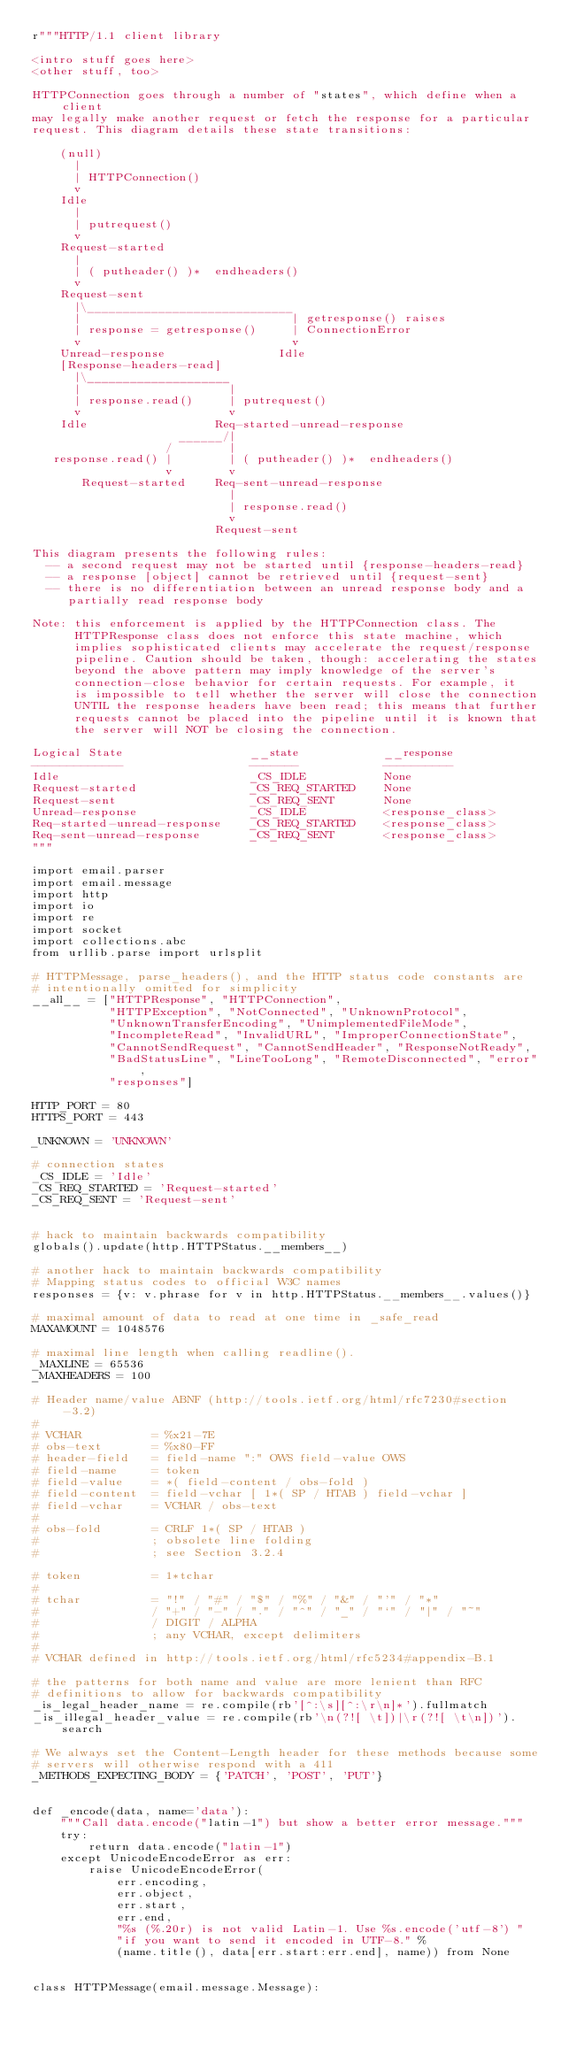Convert code to text. <code><loc_0><loc_0><loc_500><loc_500><_Python_>r"""HTTP/1.1 client library

<intro stuff goes here>
<other stuff, too>

HTTPConnection goes through a number of "states", which define when a client
may legally make another request or fetch the response for a particular
request. This diagram details these state transitions:

    (null)
      |
      | HTTPConnection()
      v
    Idle
      |
      | putrequest()
      v
    Request-started
      |
      | ( putheader() )*  endheaders()
      v
    Request-sent
      |\_____________________________
      |                              | getresponse() raises
      | response = getresponse()     | ConnectionError
      v                              v
    Unread-response                Idle
    [Response-headers-read]
      |\____________________
      |                     |
      | response.read()     | putrequest()
      v                     v
    Idle                  Req-started-unread-response
                     ______/|
                   /        |
   response.read() |        | ( putheader() )*  endheaders()
                   v        v
       Request-started    Req-sent-unread-response
                            |
                            | response.read()
                            v
                          Request-sent

This diagram presents the following rules:
  -- a second request may not be started until {response-headers-read}
  -- a response [object] cannot be retrieved until {request-sent}
  -- there is no differentiation between an unread response body and a
     partially read response body

Note: this enforcement is applied by the HTTPConnection class. The
      HTTPResponse class does not enforce this state machine, which
      implies sophisticated clients may accelerate the request/response
      pipeline. Caution should be taken, though: accelerating the states
      beyond the above pattern may imply knowledge of the server's
      connection-close behavior for certain requests. For example, it
      is impossible to tell whether the server will close the connection
      UNTIL the response headers have been read; this means that further
      requests cannot be placed into the pipeline until it is known that
      the server will NOT be closing the connection.

Logical State                  __state            __response
-------------                  -------            ----------
Idle                           _CS_IDLE           None
Request-started                _CS_REQ_STARTED    None
Request-sent                   _CS_REQ_SENT       None
Unread-response                _CS_IDLE           <response_class>
Req-started-unread-response    _CS_REQ_STARTED    <response_class>
Req-sent-unread-response       _CS_REQ_SENT       <response_class>
"""

import email.parser
import email.message
import http
import io
import re
import socket
import collections.abc
from urllib.parse import urlsplit

# HTTPMessage, parse_headers(), and the HTTP status code constants are
# intentionally omitted for simplicity
__all__ = ["HTTPResponse", "HTTPConnection",
           "HTTPException", "NotConnected", "UnknownProtocol",
           "UnknownTransferEncoding", "UnimplementedFileMode",
           "IncompleteRead", "InvalidURL", "ImproperConnectionState",
           "CannotSendRequest", "CannotSendHeader", "ResponseNotReady",
           "BadStatusLine", "LineTooLong", "RemoteDisconnected", "error",
           "responses"]

HTTP_PORT = 80
HTTPS_PORT = 443

_UNKNOWN = 'UNKNOWN'

# connection states
_CS_IDLE = 'Idle'
_CS_REQ_STARTED = 'Request-started'
_CS_REQ_SENT = 'Request-sent'


# hack to maintain backwards compatibility
globals().update(http.HTTPStatus.__members__)

# another hack to maintain backwards compatibility
# Mapping status codes to official W3C names
responses = {v: v.phrase for v in http.HTTPStatus.__members__.values()}

# maximal amount of data to read at one time in _safe_read
MAXAMOUNT = 1048576

# maximal line length when calling readline().
_MAXLINE = 65536
_MAXHEADERS = 100

# Header name/value ABNF (http://tools.ietf.org/html/rfc7230#section-3.2)
#
# VCHAR          = %x21-7E
# obs-text       = %x80-FF
# header-field   = field-name ":" OWS field-value OWS
# field-name     = token
# field-value    = *( field-content / obs-fold )
# field-content  = field-vchar [ 1*( SP / HTAB ) field-vchar ]
# field-vchar    = VCHAR / obs-text
#
# obs-fold       = CRLF 1*( SP / HTAB )
#                ; obsolete line folding
#                ; see Section 3.2.4

# token          = 1*tchar
#
# tchar          = "!" / "#" / "$" / "%" / "&" / "'" / "*"
#                / "+" / "-" / "." / "^" / "_" / "`" / "|" / "~"
#                / DIGIT / ALPHA
#                ; any VCHAR, except delimiters
#
# VCHAR defined in http://tools.ietf.org/html/rfc5234#appendix-B.1

# the patterns for both name and value are more lenient than RFC
# definitions to allow for backwards compatibility
_is_legal_header_name = re.compile(rb'[^:\s][^:\r\n]*').fullmatch
_is_illegal_header_value = re.compile(rb'\n(?![ \t])|\r(?![ \t\n])').search

# We always set the Content-Length header for these methods because some
# servers will otherwise respond with a 411
_METHODS_EXPECTING_BODY = {'PATCH', 'POST', 'PUT'}


def _encode(data, name='data'):
    """Call data.encode("latin-1") but show a better error message."""
    try:
        return data.encode("latin-1")
    except UnicodeEncodeError as err:
        raise UnicodeEncodeError(
            err.encoding,
            err.object,
            err.start,
            err.end,
            "%s (%.20r) is not valid Latin-1. Use %s.encode('utf-8') "
            "if you want to send it encoded in UTF-8." %
            (name.title(), data[err.start:err.end], name)) from None


class HTTPMessage(email.message.Message):</code> 